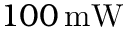Convert formula to latex. <formula><loc_0><loc_0><loc_500><loc_500>1 0 0 \, m W</formula> 